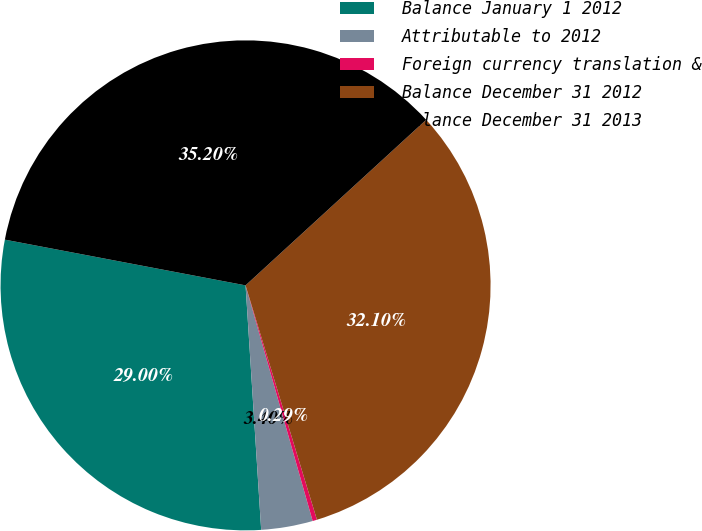Convert chart to OTSL. <chart><loc_0><loc_0><loc_500><loc_500><pie_chart><fcel>Balance January 1 2012<fcel>Attributable to 2012<fcel>Foreign currency translation &<fcel>Balance December 31 2012<fcel>Balance December 31 2013<nl><fcel>29.0%<fcel>3.4%<fcel>0.29%<fcel>32.1%<fcel>35.2%<nl></chart> 